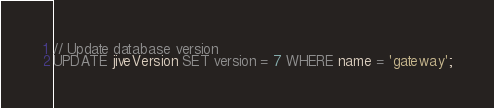<code> <loc_0><loc_0><loc_500><loc_500><_SQL_>// Update database version
UPDATE jiveVersion SET version = 7 WHERE name = 'gateway';
</code> 